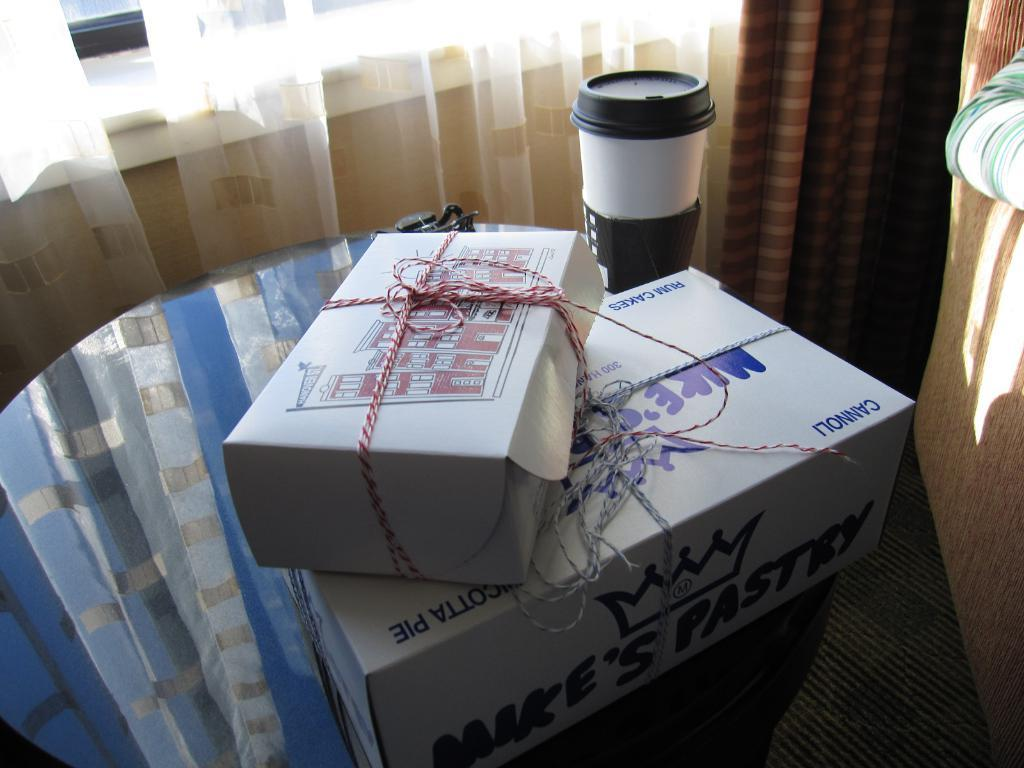<image>
Offer a succinct explanation of the picture presented. A large box from Mike's Pastry is next to a coffee cup on a glass table. 